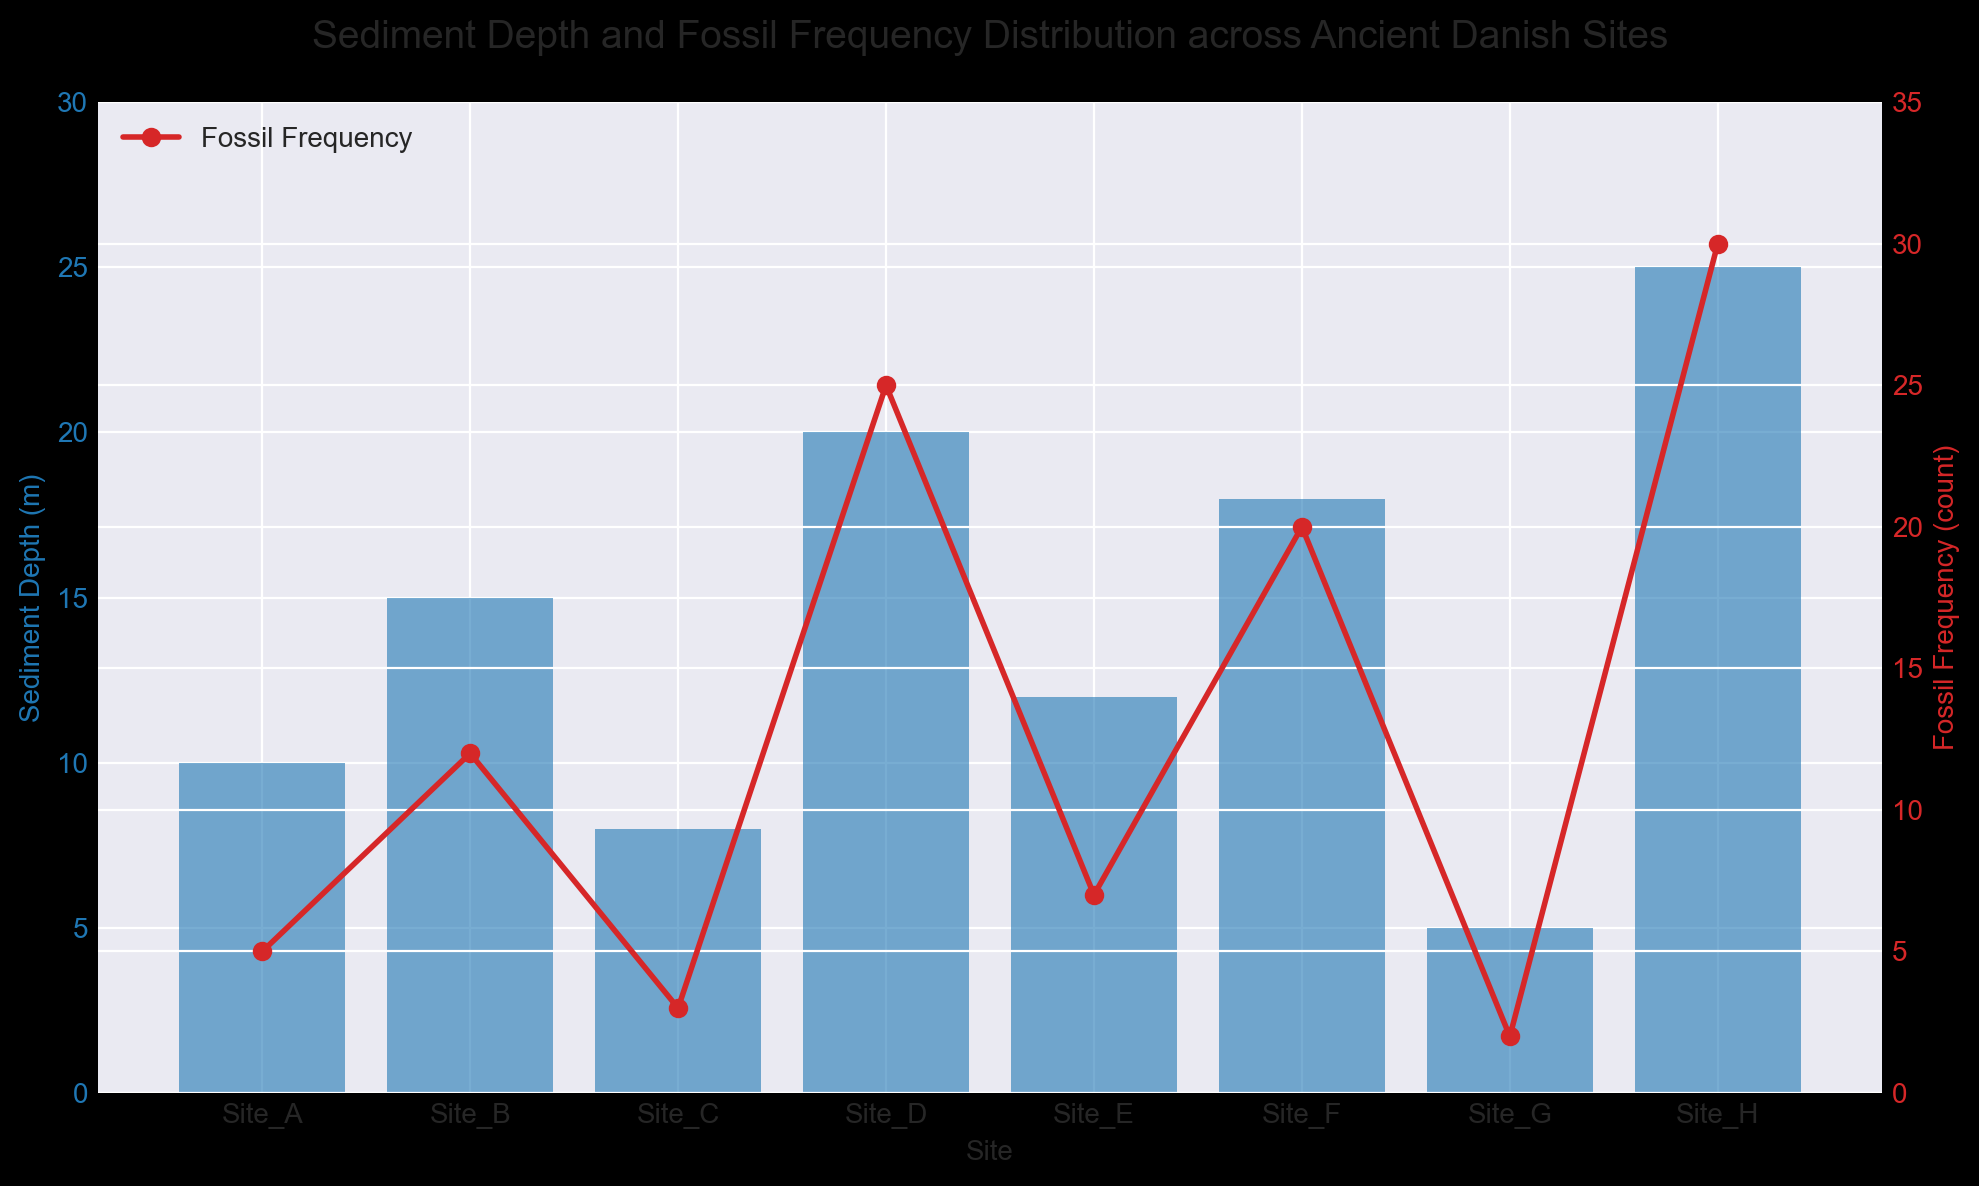Which site has the maximum sediment depth? The site with the tallest blue bar represents the maximum sediment depth. According to the plot, Site_H has the tallest blue bar, indicating the maximum sediment depth.
Answer: Site_H How does the fossil frequency at Site_F compare to Site_E? The red line with markers indicates fossil frequency. Comparing the heights of the markers, Site_F has a higher fossil frequency count (20) than Site_E (7).
Answer: Site_F has a higher fossil frequency What's the difference in sediment depth between Site_B and Site_G? Refer to the heights of the blue bars for Site_B and Site_G. Site_B’s sediment depth is 15 meters, and Site_G’s is 5 meters. The difference is calculated as 15 - 5 = 10 meters.
Answer: 10 meters Which site exhibits the lowest fossil frequency? The lowest point on the red line represents the lowest fossil frequency. Site_G, with a fossil frequency of 2, has the lowest count.
Answer: Site_G What's the average fossil frequency across all sites? Sum the fossil frequency counts (5 + 12 + 3 + 25 + 7 + 20 + 2 + 30) = 104. Divide by the number of sites (8).
104 / 8 = 13.
Answer: 13 Between Site_A and Site_H, which has the most significant difference between sediment depth and fossil frequency? Calculate the differences: Site_A has sediment depth 10m and fossil frequency 5 (difference = 10 - 5 = 5). Site_H has sediment depth 25m and fossil frequency 30 (difference = 30 - 25 = 5). Both sites have the same difference.
Answer: Both have the same difference Which site shows the closest match between sediment depth and fossil frequency? Check where the blue bar height closely matches the red marker height. Site_A (10m sediment, 5 fossils), Site_B (15m sediment, 12 fossils), and Site_C (8m sediment, 3 fossils), but Site_C has the most negligible difference (5).
Answer: Site_C On which site does the fossil frequency increase significantly despite low sediment depth? Look for sites where the red line marker is significantly higher than the blue bar. Site_D has a low sediment depth of 20m but a high fossil frequency of 25.
Answer: Site_D What is the combined sediment depth of the three shallowest sites? Identify the three sites with the shortest blue bars: Site_G (5), Site_C (8), and Site_A (10). Sum them: 5 + 8 + 10 = 23 meters.
Answer: 23 meters Which site has the highest ratio of fossil frequency to sediment depth? Calculate the ratio (fossil frequency / sediment depth) for each site. Site_H has a ratio of 30/25 = 1.2, which is higher compared to other sites.
Answer: Site_H 